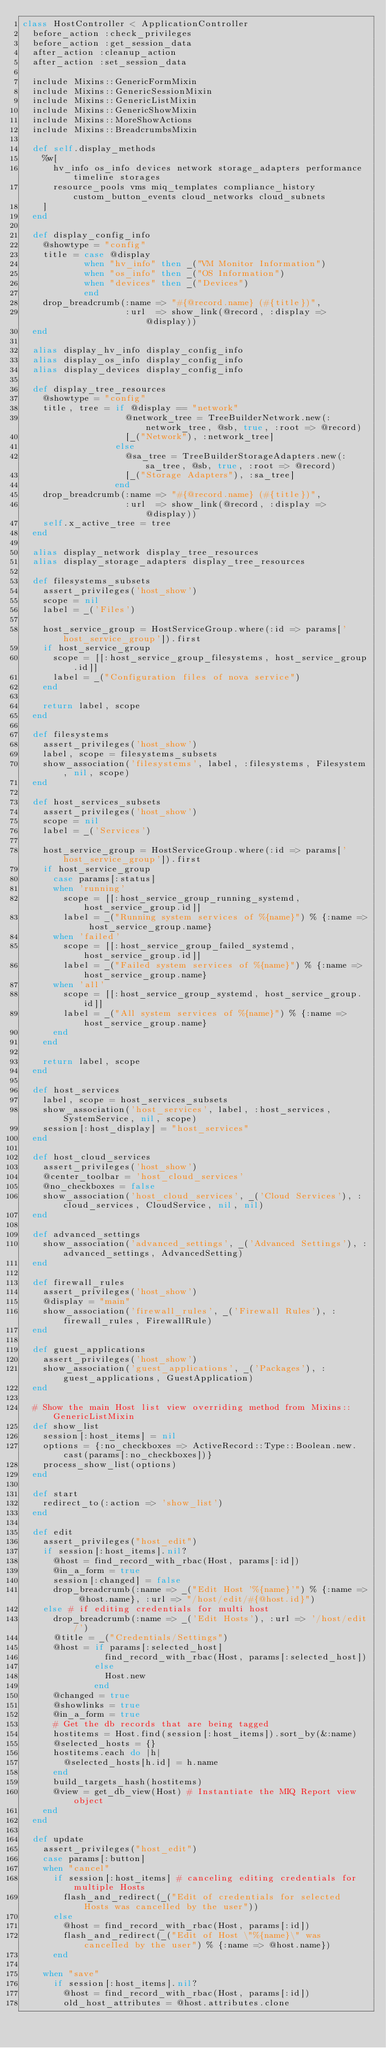Convert code to text. <code><loc_0><loc_0><loc_500><loc_500><_Ruby_>class HostController < ApplicationController
  before_action :check_privileges
  before_action :get_session_data
  after_action :cleanup_action
  after_action :set_session_data

  include Mixins::GenericFormMixin
  include Mixins::GenericSessionMixin
  include Mixins::GenericListMixin
  include Mixins::GenericShowMixin
  include Mixins::MoreShowActions
  include Mixins::BreadcrumbsMixin

  def self.display_methods
    %w[
      hv_info os_info devices network storage_adapters performance timeline storages
      resource_pools vms miq_templates compliance_history custom_button_events cloud_networks cloud_subnets
    ]
  end

  def display_config_info
    @showtype = "config"
    title = case @display
            when "hv_info" then _("VM Monitor Information")
            when "os_info" then _("OS Information")
            when "devices" then _("Devices")
            end
    drop_breadcrumb(:name => "#{@record.name} (#{title})",
                    :url  => show_link(@record, :display => @display))
  end

  alias display_hv_info display_config_info
  alias display_os_info display_config_info
  alias display_devices display_config_info

  def display_tree_resources
    @showtype = "config"
    title, tree = if @display == "network"
                    @network_tree = TreeBuilderNetwork.new(:network_tree, @sb, true, :root => @record)
                    [_("Network"), :network_tree]
                  else
                    @sa_tree = TreeBuilderStorageAdapters.new(:sa_tree, @sb, true, :root => @record)
                    [_("Storage Adapters"), :sa_tree]
                  end
    drop_breadcrumb(:name => "#{@record.name} (#{title})",
                    :url  => show_link(@record, :display => @display))
    self.x_active_tree = tree
  end

  alias display_network display_tree_resources
  alias display_storage_adapters display_tree_resources

  def filesystems_subsets
    assert_privileges('host_show')
    scope = nil
    label = _('Files')

    host_service_group = HostServiceGroup.where(:id => params['host_service_group']).first
    if host_service_group
      scope = [[:host_service_group_filesystems, host_service_group.id]]
      label = _("Configuration files of nova service")
    end

    return label, scope
  end

  def filesystems
    assert_privileges('host_show')
    label, scope = filesystems_subsets
    show_association('filesystems', label, :filesystems, Filesystem, nil, scope)
  end

  def host_services_subsets
    assert_privileges('host_show')
    scope = nil
    label = _('Services')

    host_service_group = HostServiceGroup.where(:id => params['host_service_group']).first
    if host_service_group
      case params[:status]
      when 'running'
        scope = [[:host_service_group_running_systemd, host_service_group.id]]
        label = _("Running system services of %{name}") % {:name => host_service_group.name}
      when 'failed'
        scope = [[:host_service_group_failed_systemd, host_service_group.id]]
        label = _("Failed system services of %{name}") % {:name => host_service_group.name}
      when 'all'
        scope = [[:host_service_group_systemd, host_service_group.id]]
        label = _("All system services of %{name}") % {:name => host_service_group.name}
      end
    end

    return label, scope
  end

  def host_services
    label, scope = host_services_subsets
    show_association('host_services', label, :host_services, SystemService, nil, scope)
    session[:host_display] = "host_services"
  end

  def host_cloud_services
    assert_privileges('host_show')
    @center_toolbar = 'host_cloud_services'
    @no_checkboxes = false
    show_association('host_cloud_services', _('Cloud Services'), :cloud_services, CloudService, nil, nil)
  end

  def advanced_settings
    show_association('advanced_settings', _('Advanced Settings'), :advanced_settings, AdvancedSetting)
  end

  def firewall_rules
    assert_privileges('host_show')
    @display = "main"
    show_association('firewall_rules', _('Firewall Rules'), :firewall_rules, FirewallRule)
  end

  def guest_applications
    assert_privileges('host_show')
    show_association('guest_applications', _('Packages'), :guest_applications, GuestApplication)
  end

  # Show the main Host list view overriding method from Mixins::GenericListMixin
  def show_list
    session[:host_items] = nil
    options = {:no_checkboxes => ActiveRecord::Type::Boolean.new.cast(params[:no_checkboxes])}
    process_show_list(options)
  end

  def start
    redirect_to(:action => 'show_list')
  end

  def edit
    assert_privileges("host_edit")
    if session[:host_items].nil?
      @host = find_record_with_rbac(Host, params[:id])
      @in_a_form = true
      session[:changed] = false
      drop_breadcrumb(:name => _("Edit Host '%{name}'") % {:name => @host.name}, :url => "/host/edit/#{@host.id}")
    else # if editing credentials for multi host
      drop_breadcrumb(:name => _('Edit Hosts'), :url => '/host/edit/')
      @title = _("Credentials/Settings")
      @host = if params[:selected_host]
                find_record_with_rbac(Host, params[:selected_host])
              else
                Host.new
              end
      @changed = true
      @showlinks = true
      @in_a_form = true
      # Get the db records that are being tagged
      hostitems = Host.find(session[:host_items]).sort_by(&:name)
      @selected_hosts = {}
      hostitems.each do |h|
        @selected_hosts[h.id] = h.name
      end
      build_targets_hash(hostitems)
      @view = get_db_view(Host) # Instantiate the MIQ Report view object
    end
  end

  def update
    assert_privileges("host_edit")
    case params[:button]
    when "cancel"
      if session[:host_items] # canceling editing credentials for multiple Hosts
        flash_and_redirect(_("Edit of credentials for selected Hosts was cancelled by the user"))
      else
        @host = find_record_with_rbac(Host, params[:id])
        flash_and_redirect(_("Edit of Host \"%{name}\" was cancelled by the user") % {:name => @host.name})
      end

    when "save"
      if session[:host_items].nil?
        @host = find_record_with_rbac(Host, params[:id])
        old_host_attributes = @host.attributes.clone</code> 